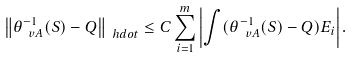Convert formula to latex. <formula><loc_0><loc_0><loc_500><loc_500>\left \| \theta _ { \ v A } ^ { - 1 } ( S ) - Q \right \| _ { \ h d o t } \leq C \sum _ { i = 1 } ^ { m } \left | \int ( \theta _ { \ v A } ^ { - 1 } ( S ) - Q ) E _ { i } \right | .</formula> 